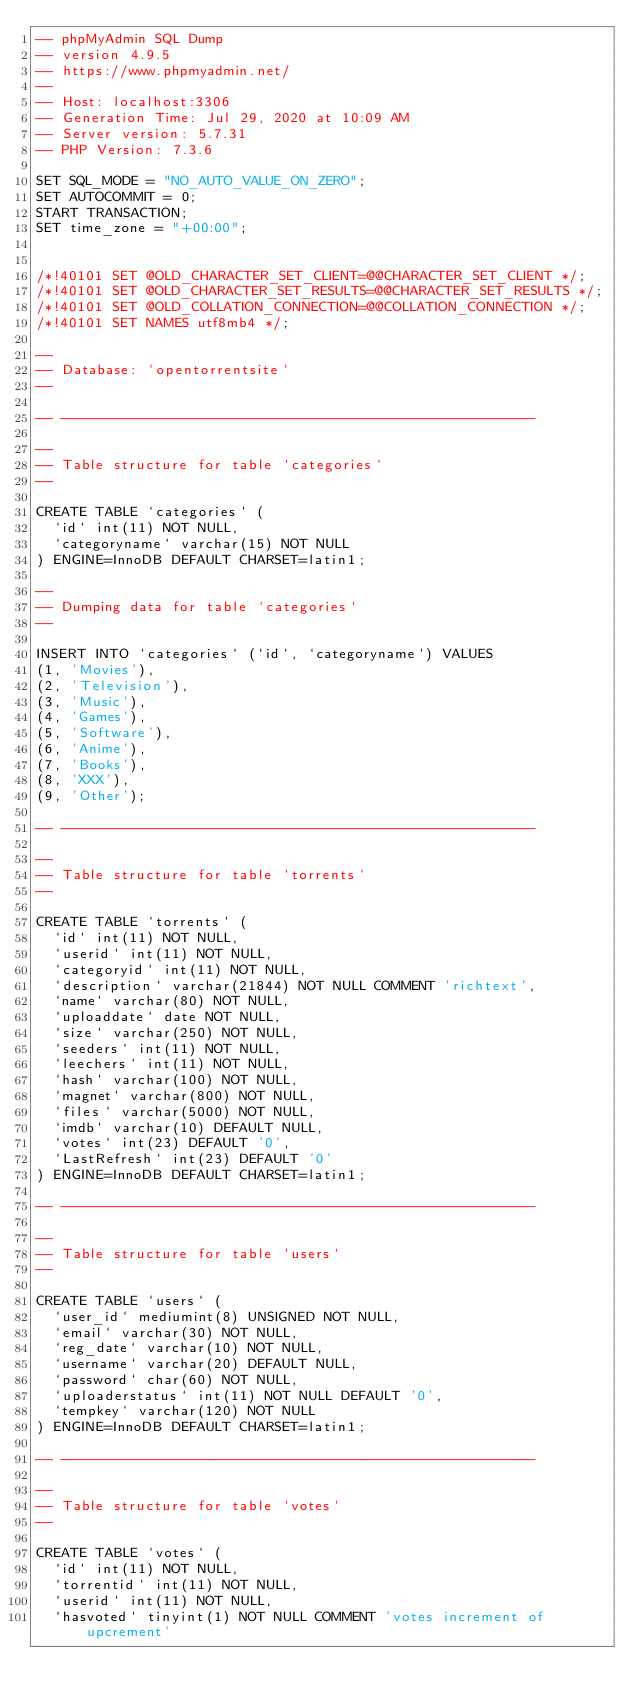Convert code to text. <code><loc_0><loc_0><loc_500><loc_500><_SQL_>-- phpMyAdmin SQL Dump
-- version 4.9.5
-- https://www.phpmyadmin.net/
--
-- Host: localhost:3306
-- Generation Time: Jul 29, 2020 at 10:09 AM
-- Server version: 5.7.31
-- PHP Version: 7.3.6

SET SQL_MODE = "NO_AUTO_VALUE_ON_ZERO";
SET AUTOCOMMIT = 0;
START TRANSACTION;
SET time_zone = "+00:00";


/*!40101 SET @OLD_CHARACTER_SET_CLIENT=@@CHARACTER_SET_CLIENT */;
/*!40101 SET @OLD_CHARACTER_SET_RESULTS=@@CHARACTER_SET_RESULTS */;
/*!40101 SET @OLD_COLLATION_CONNECTION=@@COLLATION_CONNECTION */;
/*!40101 SET NAMES utf8mb4 */;

--
-- Database: `opentorrentsite`
--

-- --------------------------------------------------------

--
-- Table structure for table `categories`
--

CREATE TABLE `categories` (
  `id` int(11) NOT NULL,
  `categoryname` varchar(15) NOT NULL
) ENGINE=InnoDB DEFAULT CHARSET=latin1;

--
-- Dumping data for table `categories`
--

INSERT INTO `categories` (`id`, `categoryname`) VALUES
(1, 'Movies'),
(2, 'Television'),
(3, 'Music'),
(4, 'Games'),
(5, 'Software'),
(6, 'Anime'),
(7, 'Books'),
(8, 'XXX'),
(9, 'Other');

-- --------------------------------------------------------

--
-- Table structure for table `torrents`
--

CREATE TABLE `torrents` (
  `id` int(11) NOT NULL,
  `userid` int(11) NOT NULL,
  `categoryid` int(11) NOT NULL,
  `description` varchar(21844) NOT NULL COMMENT 'richtext',
  `name` varchar(80) NOT NULL,
  `uploaddate` date NOT NULL,
  `size` varchar(250) NOT NULL,
  `seeders` int(11) NOT NULL,
  `leechers` int(11) NOT NULL,
  `hash` varchar(100) NOT NULL,
  `magnet` varchar(800) NOT NULL,
  `files` varchar(5000) NOT NULL,
  `imdb` varchar(10) DEFAULT NULL,
  `votes` int(23) DEFAULT '0',
  `LastRefresh` int(23) DEFAULT '0'
) ENGINE=InnoDB DEFAULT CHARSET=latin1;

-- --------------------------------------------------------

--
-- Table structure for table `users`
--

CREATE TABLE `users` (
  `user_id` mediumint(8) UNSIGNED NOT NULL,
  `email` varchar(30) NOT NULL,
  `reg_date` varchar(10) NOT NULL,
  `username` varchar(20) DEFAULT NULL,
  `password` char(60) NOT NULL,
  `uploaderstatus` int(11) NOT NULL DEFAULT '0',
  `tempkey` varchar(120) NOT NULL
) ENGINE=InnoDB DEFAULT CHARSET=latin1;

-- --------------------------------------------------------

--
-- Table structure for table `votes`
--

CREATE TABLE `votes` (
  `id` int(11) NOT NULL,
  `torrentid` int(11) NOT NULL,
  `userid` int(11) NOT NULL,
  `hasvoted` tinyint(1) NOT NULL COMMENT 'votes increment of upcrement'</code> 